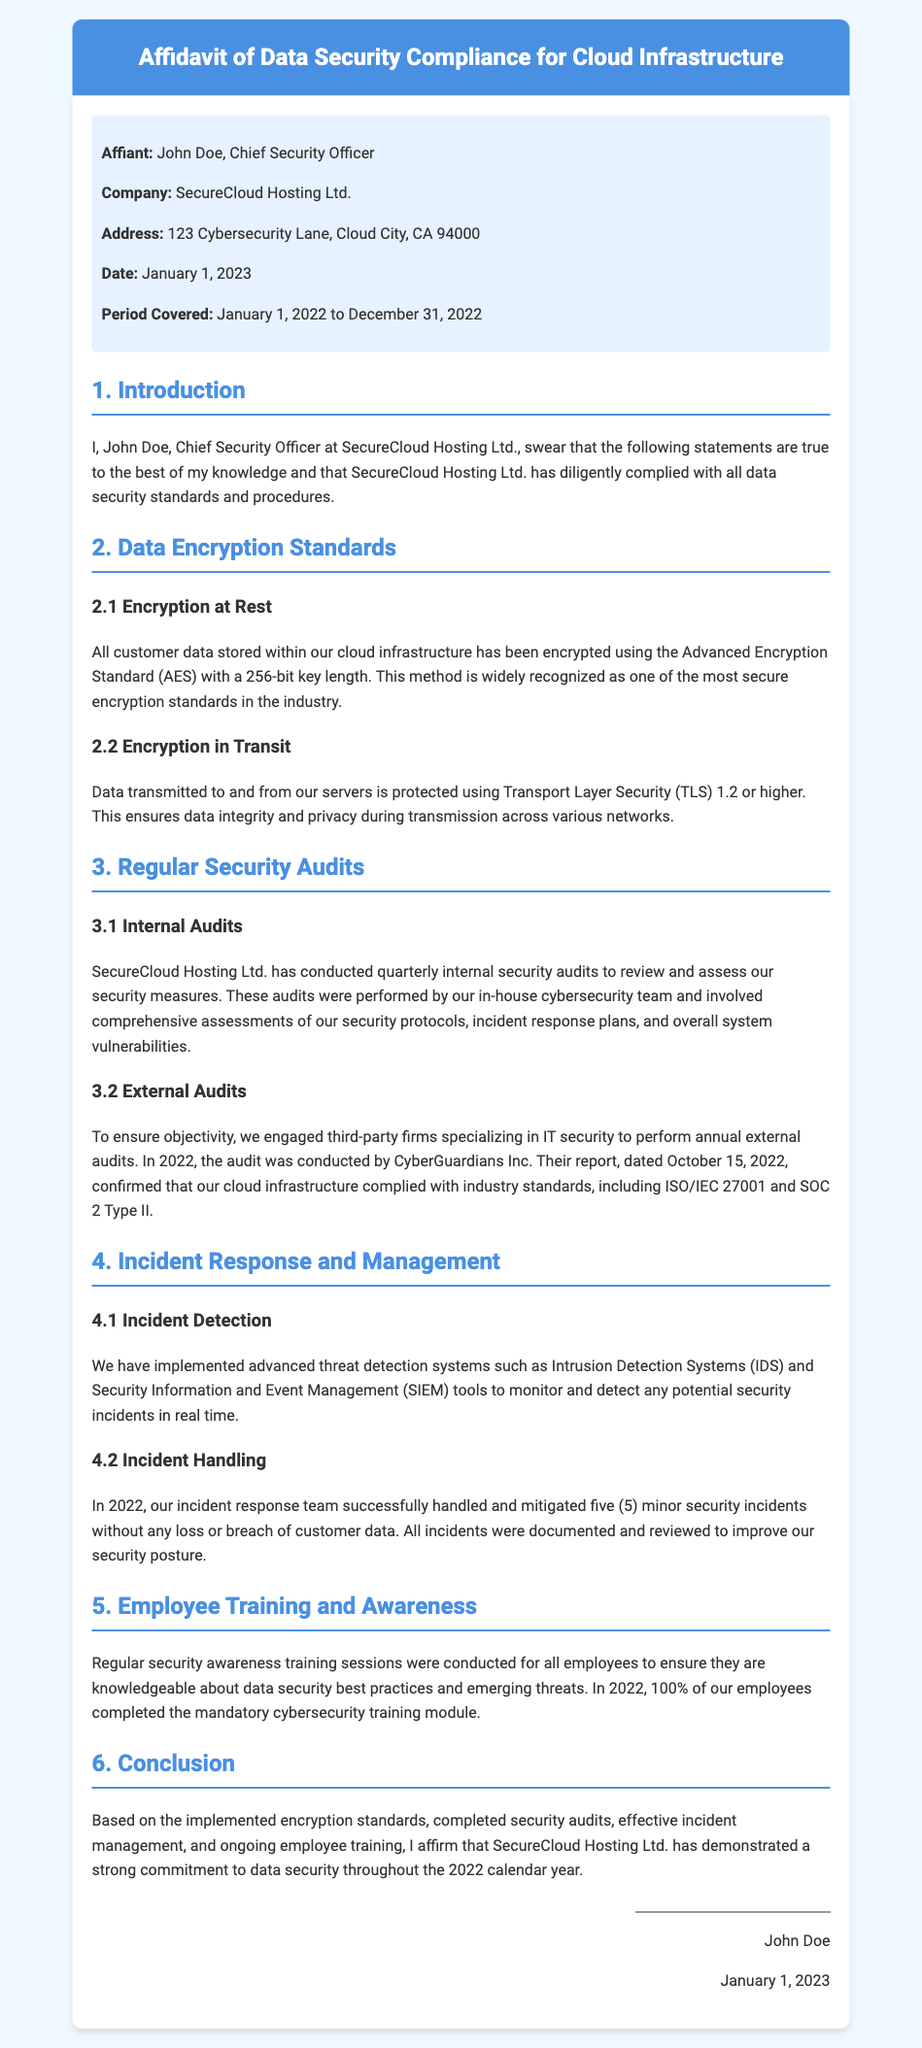What is the name of the affiant? The affiant is the person who swears to the statements made in the affidavit, which in this case is John Doe.
Answer: John Doe What is the company name? The company referred to in the affidavit is the organization where the affiant works, specified as SecureCloud Hosting Ltd.
Answer: SecureCloud Hosting Ltd What is the address of the company? The address provides the physical location of the company, which is listed as 123 Cybersecurity Lane, Cloud City, CA 94000.
Answer: 123 Cybersecurity Lane, Cloud City, CA 94000 What encryption standard is used for data at rest? The document specifies that the Advanced Encryption Standard (AES) with a 256-bit key length is used for data at rest.
Answer: AES with 256-bit How many internal security audits were conducted in 2022? The number of internal audits conducted is specified in the document as quarterly, which means four audits were performed.
Answer: Four Who conducted the external audit in 2022? The affidavit names the third-party firm that performed the external audit, which is CyberGuardians Inc.
Answer: CyberGuardians Inc How many minor security incidents were managed in 2022? The affidavit details the number of incidents handled, which is stated as five minor incidents.
Answer: Five What was the completion percentage of the cybersecurity training module by employees? The document indicates that 100% of employees completed the training module regarding cybersecurity.
Answer: 100% When was the external audit report confirmed? The date when the external audit report was confirmed is mentioned in the document, specified as October 15, 2022.
Answer: October 15, 2022 